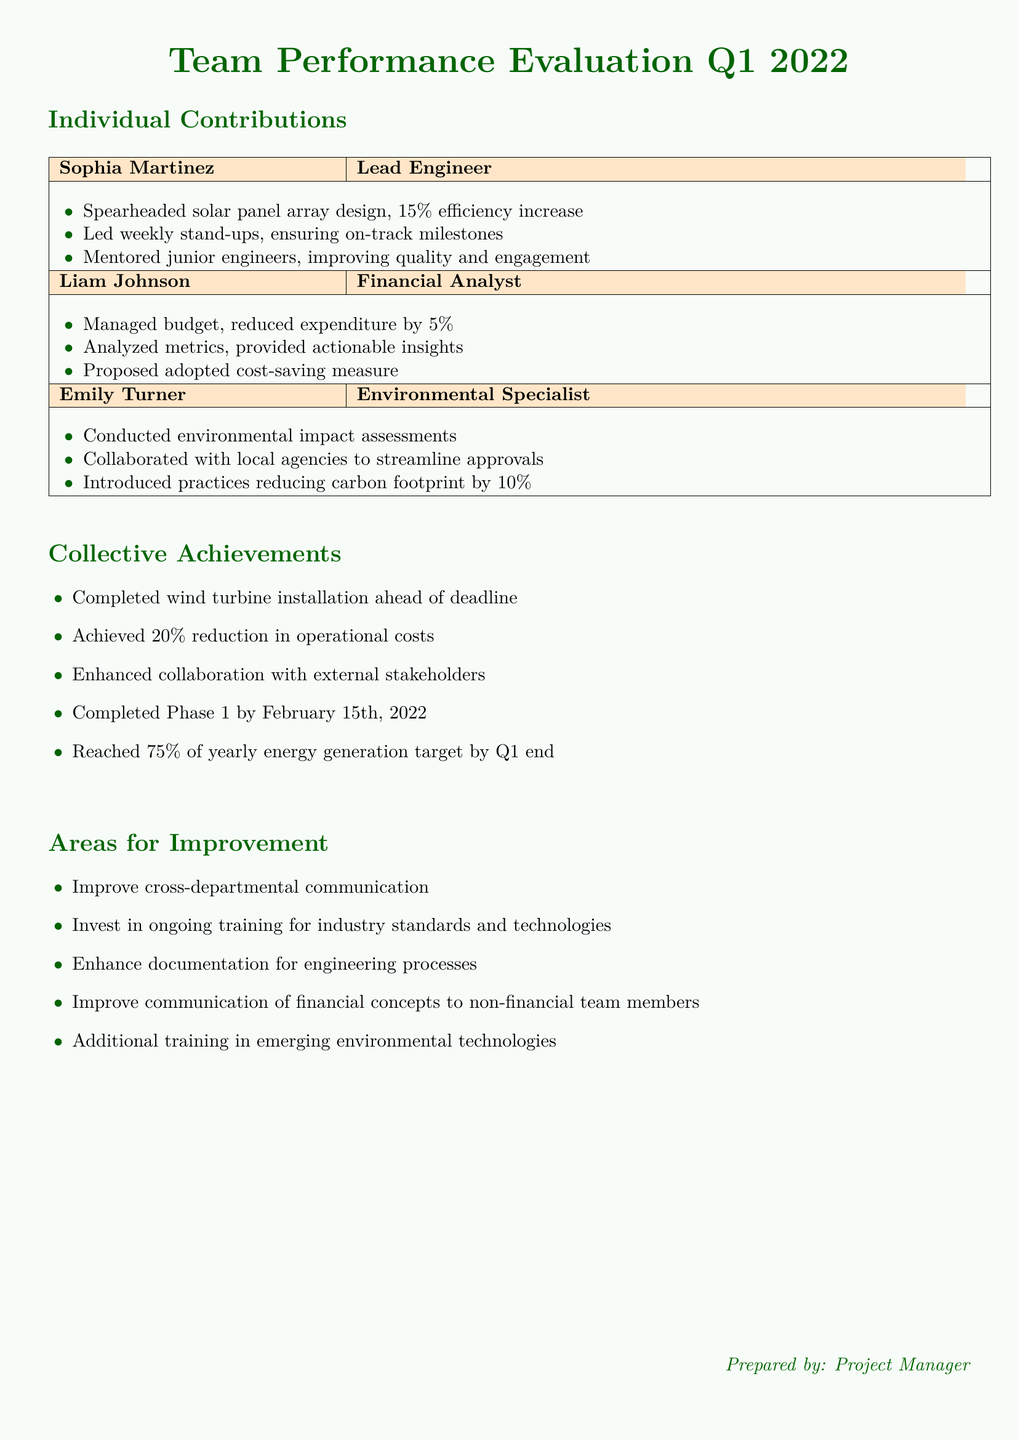What is the name of the Lead Engineer? The Lead Engineer is listed in the Individual Contributions section of the document as Sophia Martinez.
Answer: Sophia Martinez What percentage increase in efficiency did Sophia achieve? The document states that Sophia Martinez spearheaded the solar panel array design with a 15% efficiency increase.
Answer: 15% Which milestone was completed by February 15th, 2022? According to the Collective Achievements section, Phase 1 was completed by February 15th, 2022.
Answer: Phase 1 What is Liam Johnson's role? Liam Johnson is described as the Financial Analyst in the Individual Contributions section of the document.
Answer: Financial Analyst What was the percentage reduction in operational costs achieved by the team? The document mentions a 20% reduction in operational costs as part of the Collective Achievements.
Answer: 20% What area for improvement relates to training? One of the areas for improvement in the document highlights the necessity to invest in ongoing training for industry standards and technologies.
Answer: Ongoing training How many contributions did Emily Turner make? The document outlines three specific contributions made by Emily Turner in the Individual Contributions section.
Answer: Three What was the total reduction in carbon footprint introduced by Emily's practices? Emily Turner introduced practices that reduced the carbon footprint by 10%.
Answer: 10% What does the document suggest is needed for cross-departmental communication? The document identifies that improving cross-departmental communication is an area for improvement.
Answer: Improve communication 